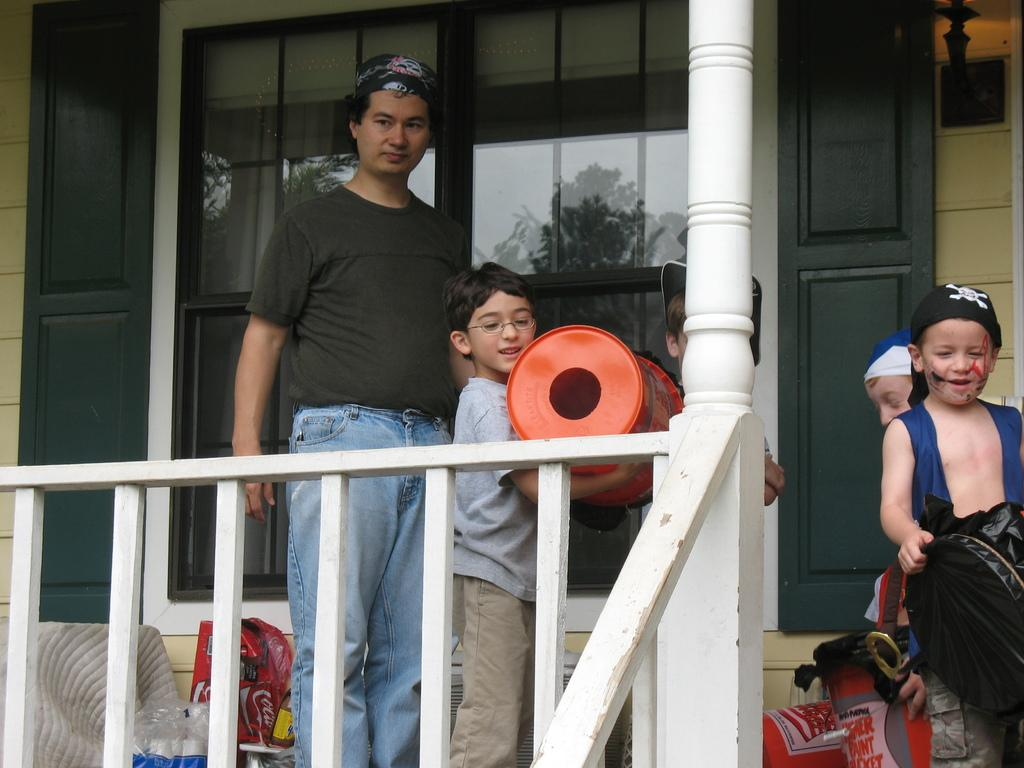What is located on the left side of the image? There is a person standing on the left side of the image. Who else is present in the image besides the person? There are children in the image. What type of barrier can be seen in the image? There is a wooden fence in the image. What material are the windows made of in the image? There are glass windows in the image. Can you see any kittens playing with a string in the image? There is no kitten or string present in the image. How many snails are crawling on the wooden fence in the image? There are no snails visible on the wooden fence in the image. 